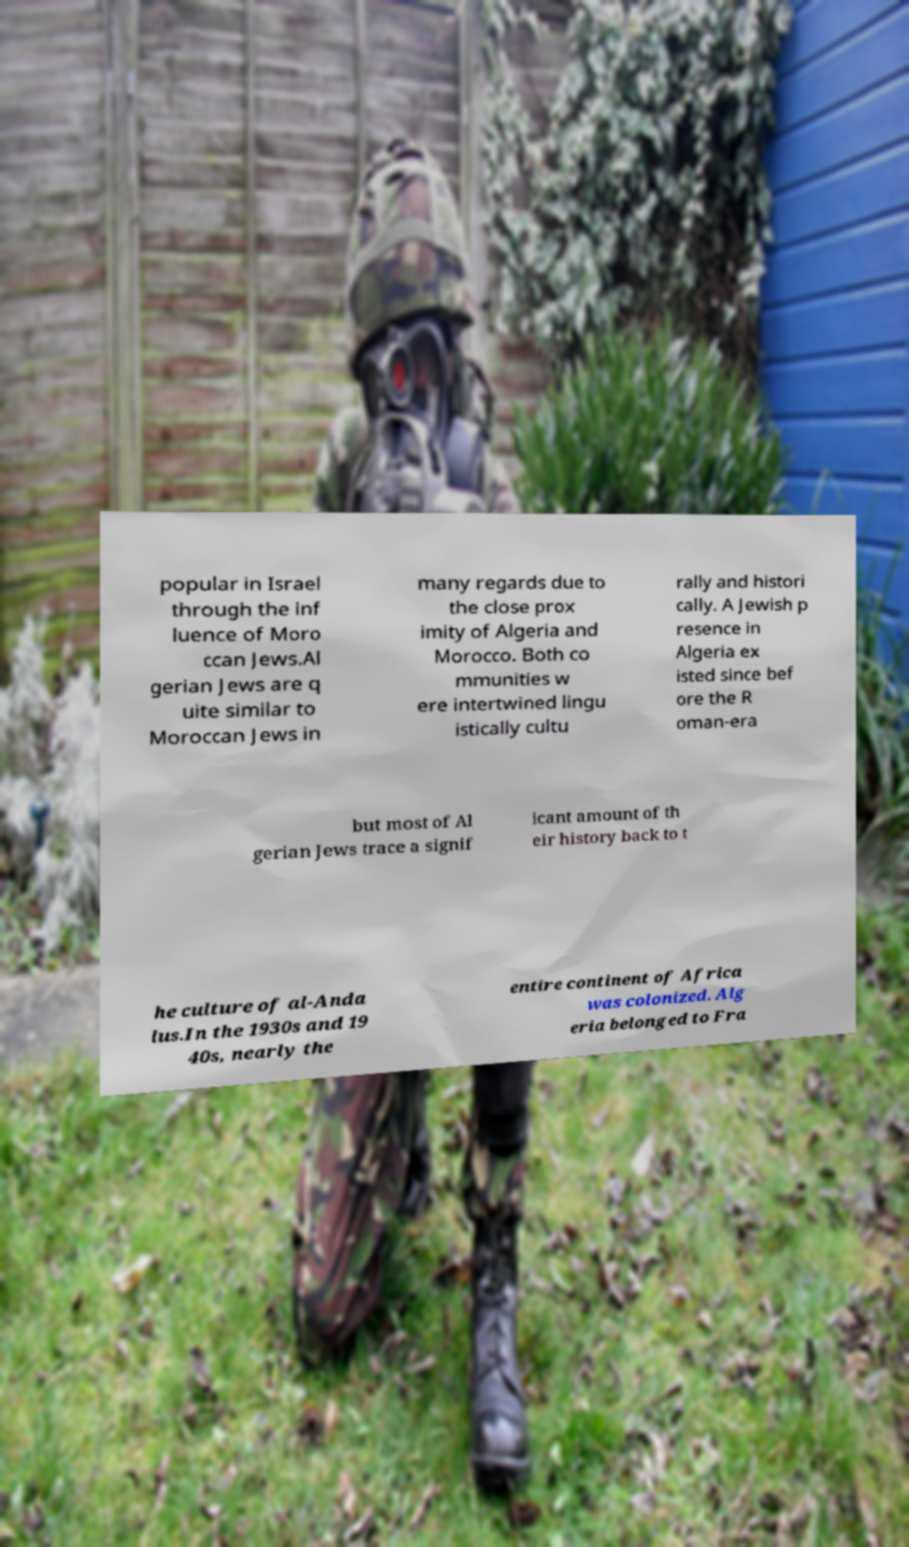Please read and relay the text visible in this image. What does it say? popular in Israel through the inf luence of Moro ccan Jews.Al gerian Jews are q uite similar to Moroccan Jews in many regards due to the close prox imity of Algeria and Morocco. Both co mmunities w ere intertwined lingu istically cultu rally and histori cally. A Jewish p resence in Algeria ex isted since bef ore the R oman-era but most of Al gerian Jews trace a signif icant amount of th eir history back to t he culture of al-Anda lus.In the 1930s and 19 40s, nearly the entire continent of Africa was colonized. Alg eria belonged to Fra 